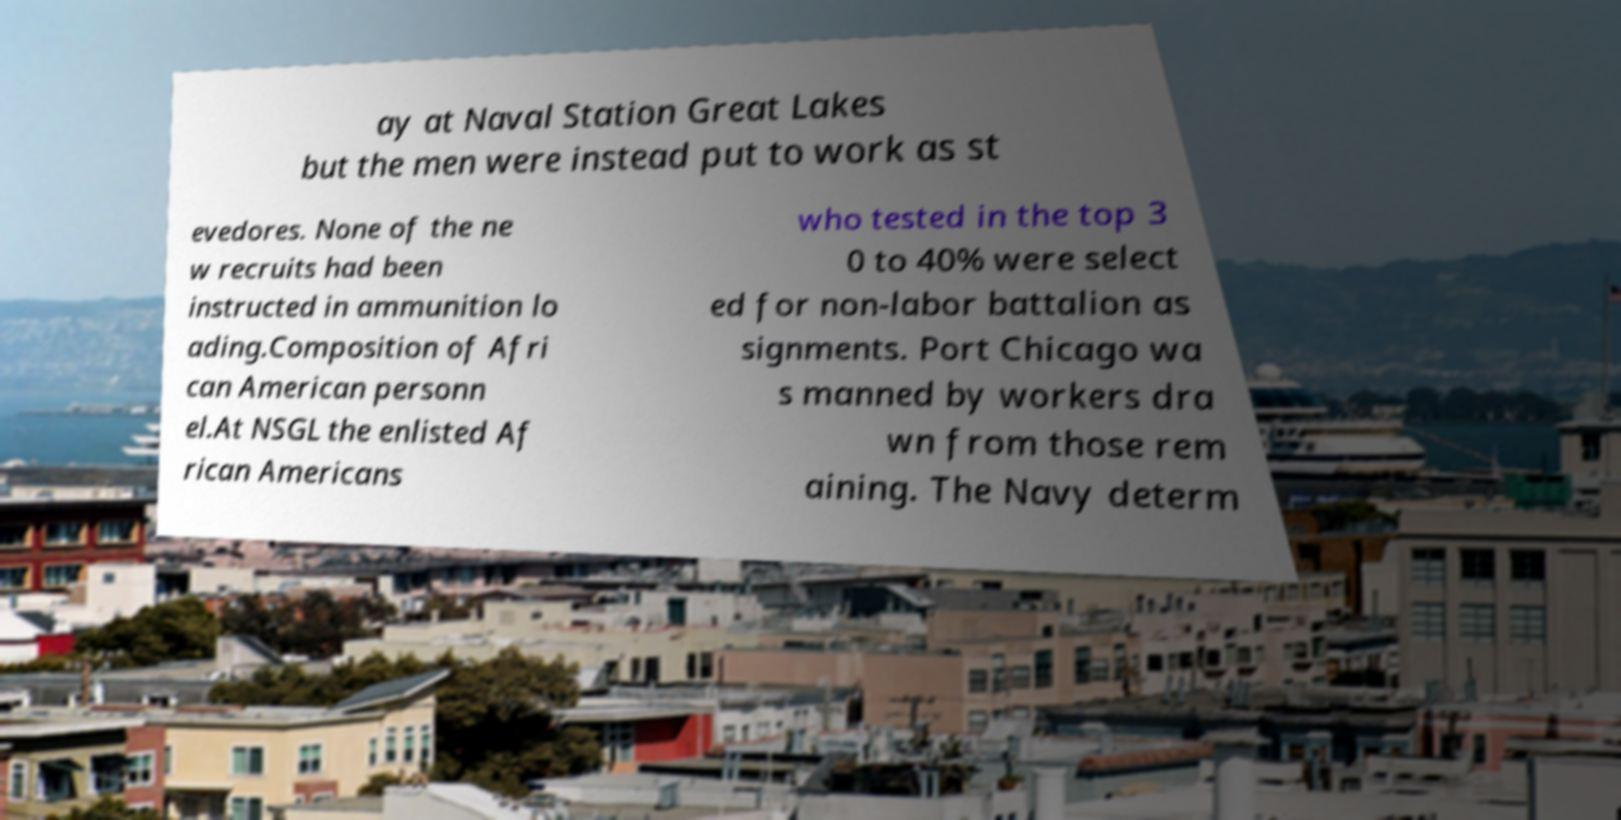What messages or text are displayed in this image? I need them in a readable, typed format. ay at Naval Station Great Lakes but the men were instead put to work as st evedores. None of the ne w recruits had been instructed in ammunition lo ading.Composition of Afri can American personn el.At NSGL the enlisted Af rican Americans who tested in the top 3 0 to 40% were select ed for non-labor battalion as signments. Port Chicago wa s manned by workers dra wn from those rem aining. The Navy determ 